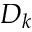<formula> <loc_0><loc_0><loc_500><loc_500>D _ { k }</formula> 